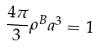Convert formula to latex. <formula><loc_0><loc_0><loc_500><loc_500>\frac { 4 \pi } { 3 } \rho ^ { B } a ^ { 3 } = 1</formula> 